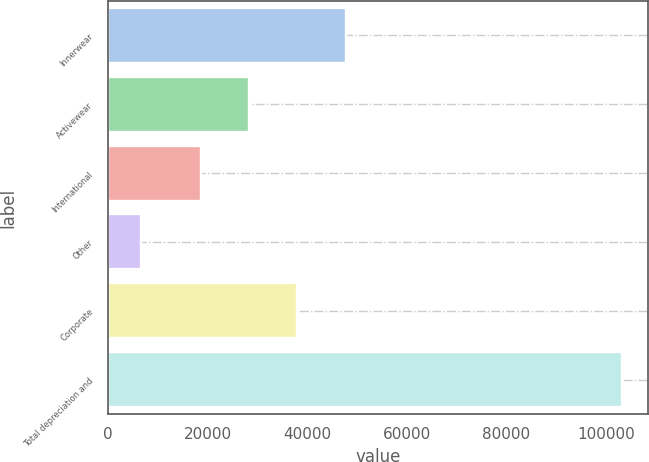<chart> <loc_0><loc_0><loc_500><loc_500><bar_chart><fcel>Innerwear<fcel>Activewear<fcel>International<fcel>Other<fcel>Corporate<fcel>Total depreciation and<nl><fcel>47673.7<fcel>28353.9<fcel>18694<fcel>6576<fcel>38013.8<fcel>103175<nl></chart> 